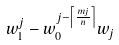<formula> <loc_0><loc_0><loc_500><loc_500>w _ { 1 } ^ { j } - w _ { 0 } ^ { j - \left \lceil \frac { m j } { n } \right \rceil } w _ { j }</formula> 